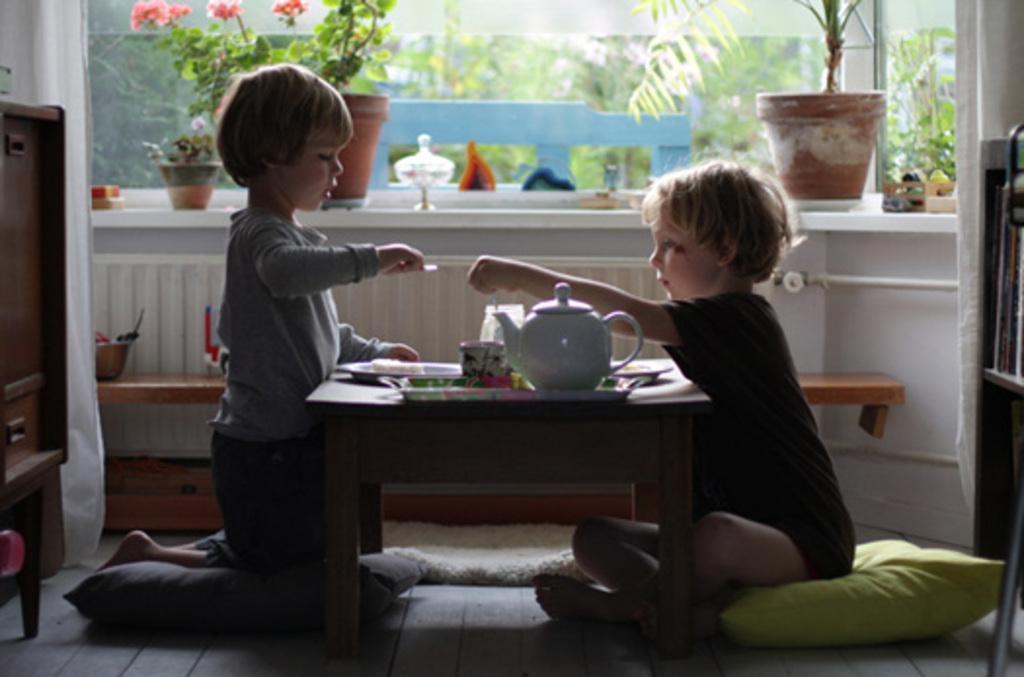Can you describe this image briefly? In the middle there is a table on the table there is a cup and jug ,plate ,some food. To the right there is a boy who is wearing a black t shirt and to the right there is a houseplant. To the left there is a boy who is wearing a gray t shirt and a trouser. There is a pillow in the bottom and to the left there is a table on the left top there is a flower. 